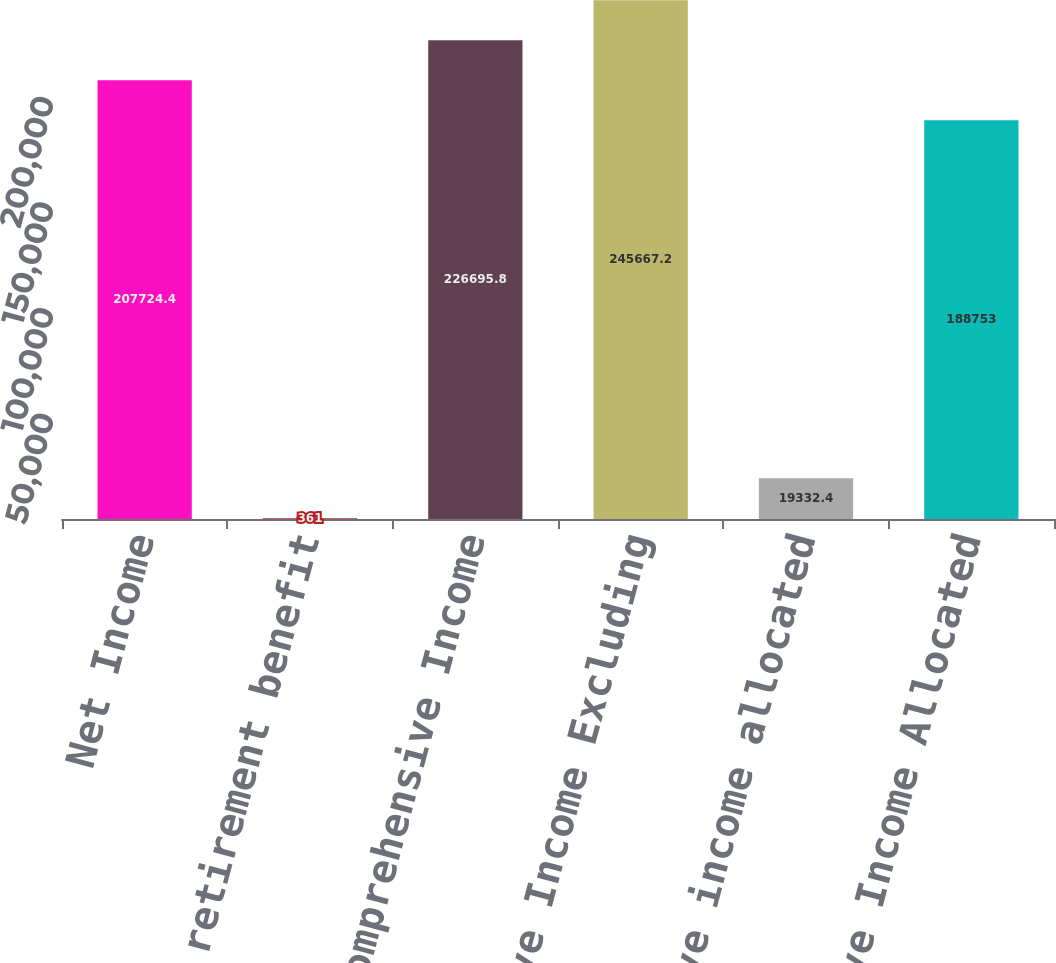Convert chart. <chart><loc_0><loc_0><loc_500><loc_500><bar_chart><fcel>Net Income<fcel>Post retirement benefit<fcel>Comprehensive Income<fcel>Comprehensive Income Excluding<fcel>Comprehensive income allocated<fcel>Comprehensive Income Allocated<nl><fcel>207724<fcel>361<fcel>226696<fcel>245667<fcel>19332.4<fcel>188753<nl></chart> 